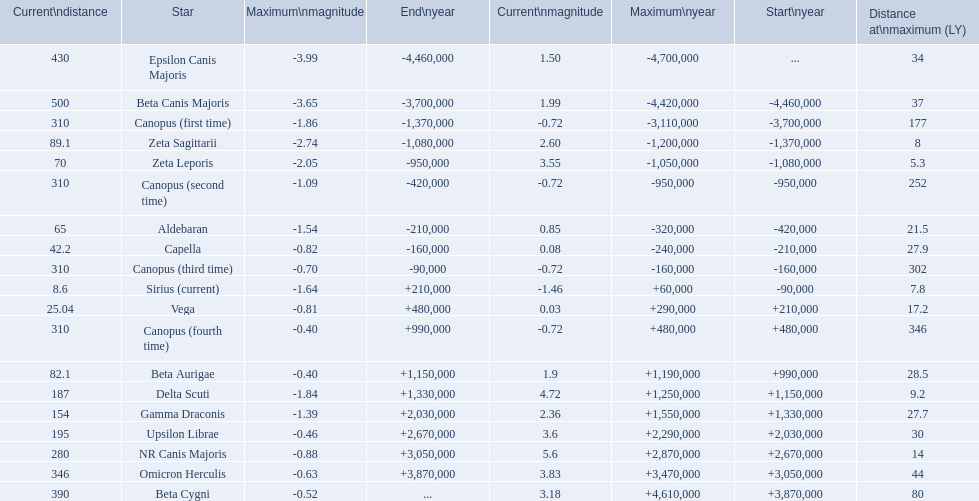Write the full table. {'header': ['Current\\ndistance', 'Star', 'Maximum\\nmagnitude', 'End\\nyear', 'Current\\nmagnitude', 'Maximum\\nyear', 'Start\\nyear', 'Distance at\\nmaximum (LY)'], 'rows': [['430', 'Epsilon Canis Majoris', '-3.99', '-4,460,000', '1.50', '-4,700,000', '...', '34'], ['500', 'Beta Canis Majoris', '-3.65', '-3,700,000', '1.99', '-4,420,000', '-4,460,000', '37'], ['310', 'Canopus (first time)', '-1.86', '-1,370,000', '-0.72', '-3,110,000', '-3,700,000', '177'], ['89.1', 'Zeta Sagittarii', '-2.74', '-1,080,000', '2.60', '-1,200,000', '-1,370,000', '8'], ['70', 'Zeta Leporis', '-2.05', '-950,000', '3.55', '-1,050,000', '-1,080,000', '5.3'], ['310', 'Canopus (second time)', '-1.09', '-420,000', '-0.72', '-950,000', '-950,000', '252'], ['65', 'Aldebaran', '-1.54', '-210,000', '0.85', '-320,000', '-420,000', '21.5'], ['42.2', 'Capella', '-0.82', '-160,000', '0.08', '-240,000', '-210,000', '27.9'], ['310', 'Canopus (third time)', '-0.70', '-90,000', '-0.72', '-160,000', '-160,000', '302'], ['8.6', 'Sirius (current)', '-1.64', '+210,000', '-1.46', '+60,000', '-90,000', '7.8'], ['25.04', 'Vega', '-0.81', '+480,000', '0.03', '+290,000', '+210,000', '17.2'], ['310', 'Canopus (fourth time)', '-0.40', '+990,000', '-0.72', '+480,000', '+480,000', '346'], ['82.1', 'Beta Aurigae', '-0.40', '+1,150,000', '1.9', '+1,190,000', '+990,000', '28.5'], ['187', 'Delta Scuti', '-1.84', '+1,330,000', '4.72', '+1,250,000', '+1,150,000', '9.2'], ['154', 'Gamma Draconis', '-1.39', '+2,030,000', '2.36', '+1,550,000', '+1,330,000', '27.7'], ['195', 'Upsilon Librae', '-0.46', '+2,670,000', '3.6', '+2,290,000', '+2,030,000', '30'], ['280', 'NR Canis Majoris', '-0.88', '+3,050,000', '5.6', '+2,870,000', '+2,670,000', '14'], ['346', 'Omicron Herculis', '-0.63', '+3,870,000', '3.83', '+3,470,000', '+3,050,000', '44'], ['390', 'Beta Cygni', '-0.52', '...', '3.18', '+4,610,000', '+3,870,000', '80']]} What are the historical brightest stars? Epsilon Canis Majoris, Beta Canis Majoris, Canopus (first time), Zeta Sagittarii, Zeta Leporis, Canopus (second time), Aldebaran, Capella, Canopus (third time), Sirius (current), Vega, Canopus (fourth time), Beta Aurigae, Delta Scuti, Gamma Draconis, Upsilon Librae, NR Canis Majoris, Omicron Herculis, Beta Cygni. Of those which star has a distance at maximum of 80 Beta Cygni. 